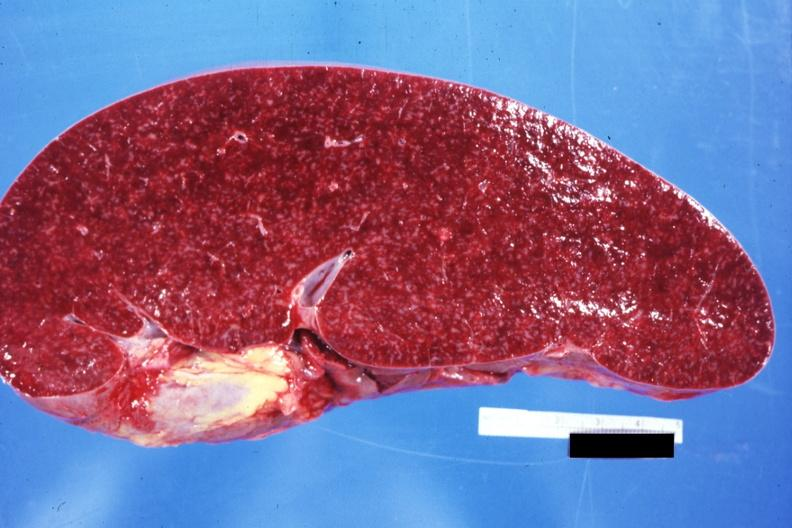s spleen present?
Answer the question using a single word or phrase. Yes 